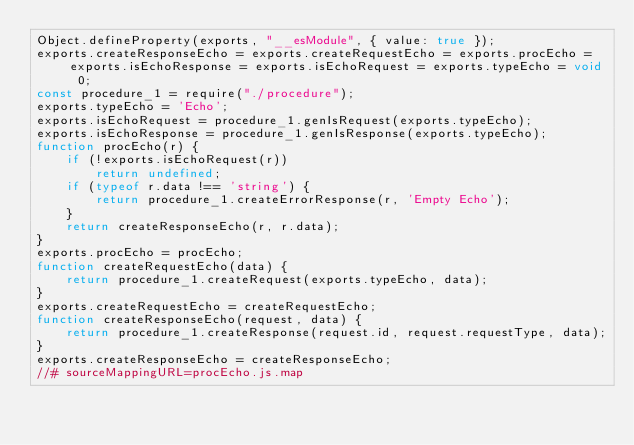<code> <loc_0><loc_0><loc_500><loc_500><_JavaScript_>Object.defineProperty(exports, "__esModule", { value: true });
exports.createResponseEcho = exports.createRequestEcho = exports.procEcho = exports.isEchoResponse = exports.isEchoRequest = exports.typeEcho = void 0;
const procedure_1 = require("./procedure");
exports.typeEcho = 'Echo';
exports.isEchoRequest = procedure_1.genIsRequest(exports.typeEcho);
exports.isEchoResponse = procedure_1.genIsResponse(exports.typeEcho);
function procEcho(r) {
    if (!exports.isEchoRequest(r))
        return undefined;
    if (typeof r.data !== 'string') {
        return procedure_1.createErrorResponse(r, 'Empty Echo');
    }
    return createResponseEcho(r, r.data);
}
exports.procEcho = procEcho;
function createRequestEcho(data) {
    return procedure_1.createRequest(exports.typeEcho, data);
}
exports.createRequestEcho = createRequestEcho;
function createResponseEcho(request, data) {
    return procedure_1.createResponse(request.id, request.requestType, data);
}
exports.createResponseEcho = createResponseEcho;
//# sourceMappingURL=procEcho.js.map</code> 